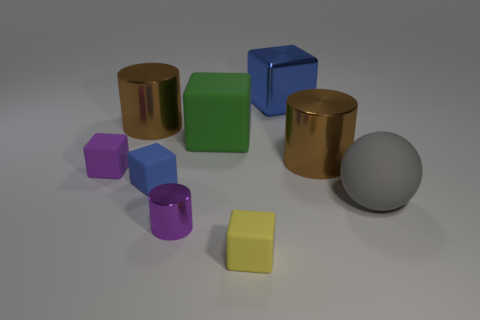Subtract all cyan cylinders. How many blue cubes are left? 2 Subtract all tiny purple cylinders. How many cylinders are left? 2 Subtract all blue blocks. How many blocks are left? 3 Subtract 2 cubes. How many cubes are left? 3 Subtract all cubes. How many objects are left? 4 Subtract all cyan spheres. Subtract all yellow cylinders. How many spheres are left? 1 Subtract all small purple metal cylinders. Subtract all big gray rubber balls. How many objects are left? 7 Add 5 small yellow cubes. How many small yellow cubes are left? 6 Add 4 large cyan shiny objects. How many large cyan shiny objects exist? 4 Subtract 0 blue cylinders. How many objects are left? 9 